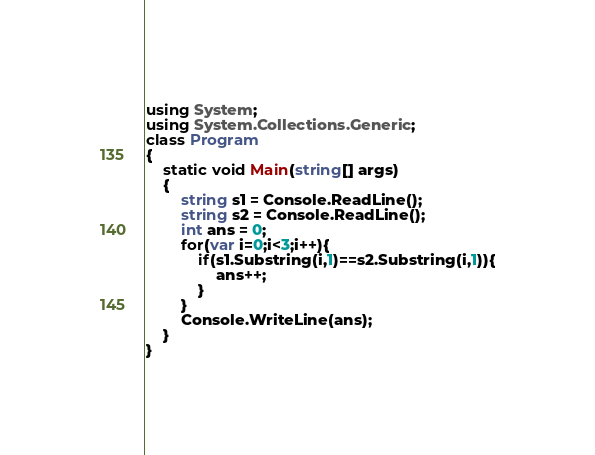Convert code to text. <code><loc_0><loc_0><loc_500><loc_500><_C#_>using System;
using System.Collections.Generic;
class Program
{
	static void Main(string[] args)
	{
		string s1 = Console.ReadLine();
		string s2 = Console.ReadLine();
		int ans = 0;
		for(var i=0;i<3;i++){
			if(s1.Substring(i,1)==s2.Substring(i,1)){
				ans++;
			}
		}
		Console.WriteLine(ans);
	}
}</code> 